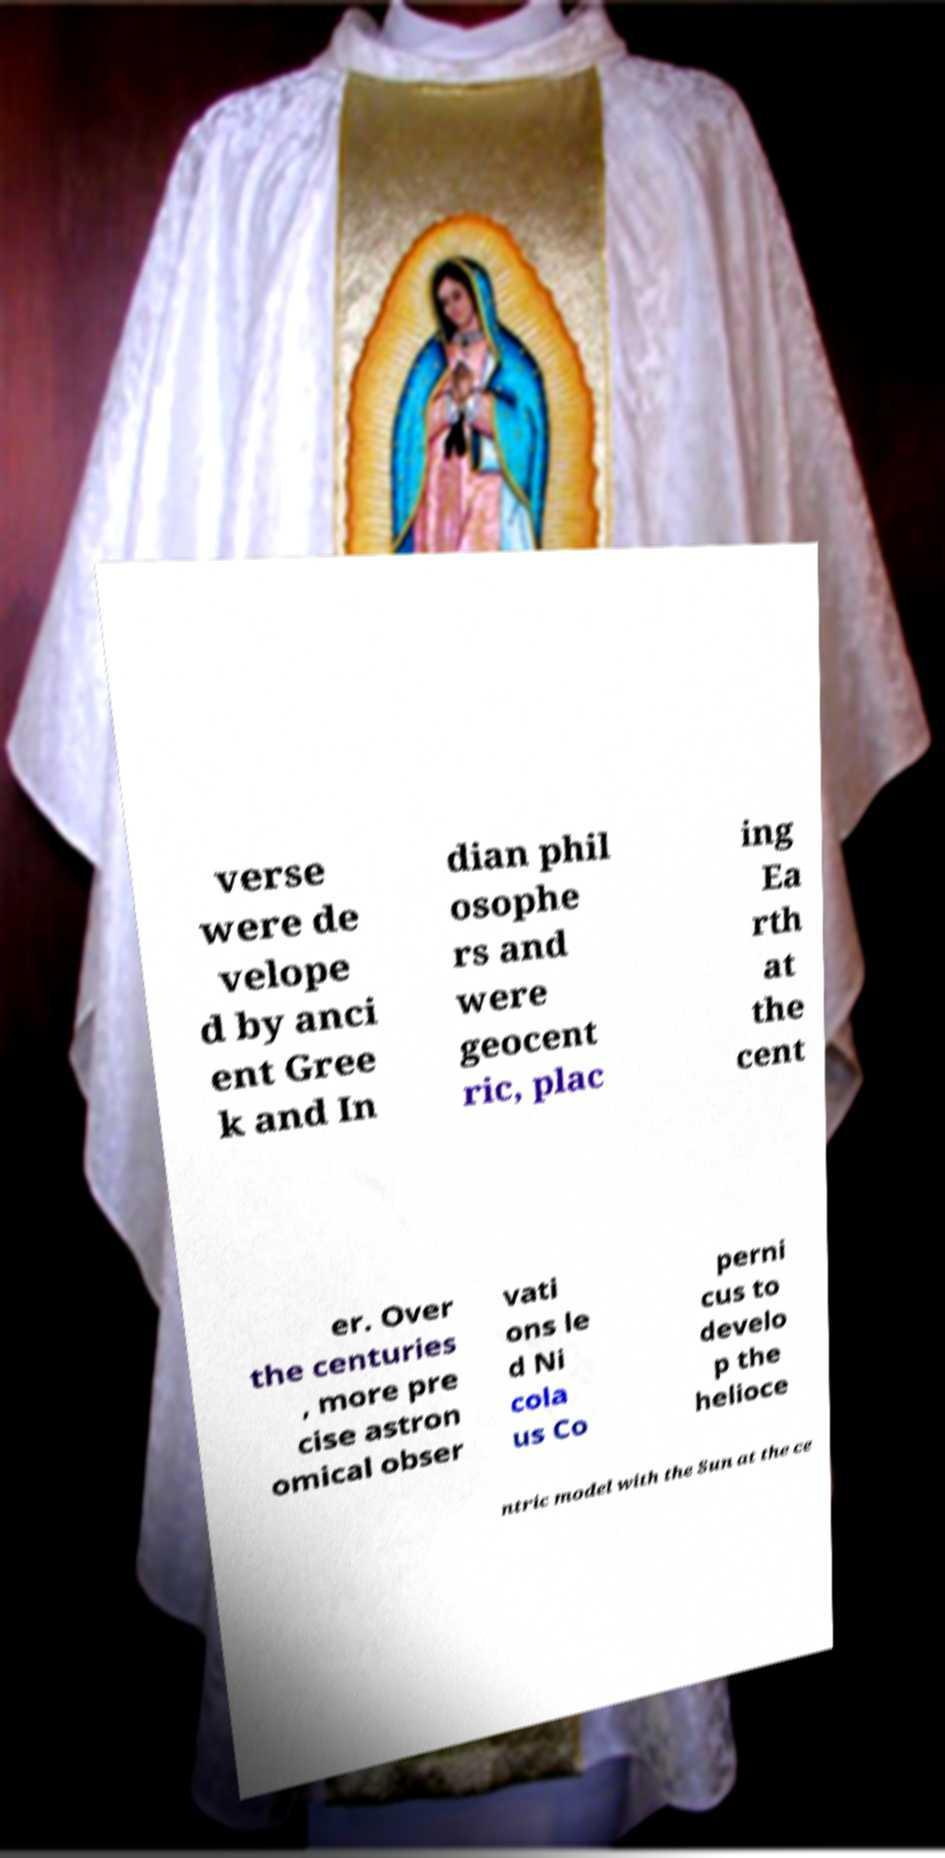For documentation purposes, I need the text within this image transcribed. Could you provide that? verse were de velope d by anci ent Gree k and In dian phil osophe rs and were geocent ric, plac ing Ea rth at the cent er. Over the centuries , more pre cise astron omical obser vati ons le d Ni cola us Co perni cus to develo p the helioce ntric model with the Sun at the ce 